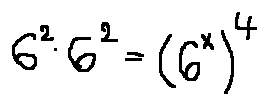<formula> <loc_0><loc_0><loc_500><loc_500>6 ^ { 6 } \cdot 6 ^ { 2 } = ( 6 ^ { x } ) ^ { 4 }</formula> 